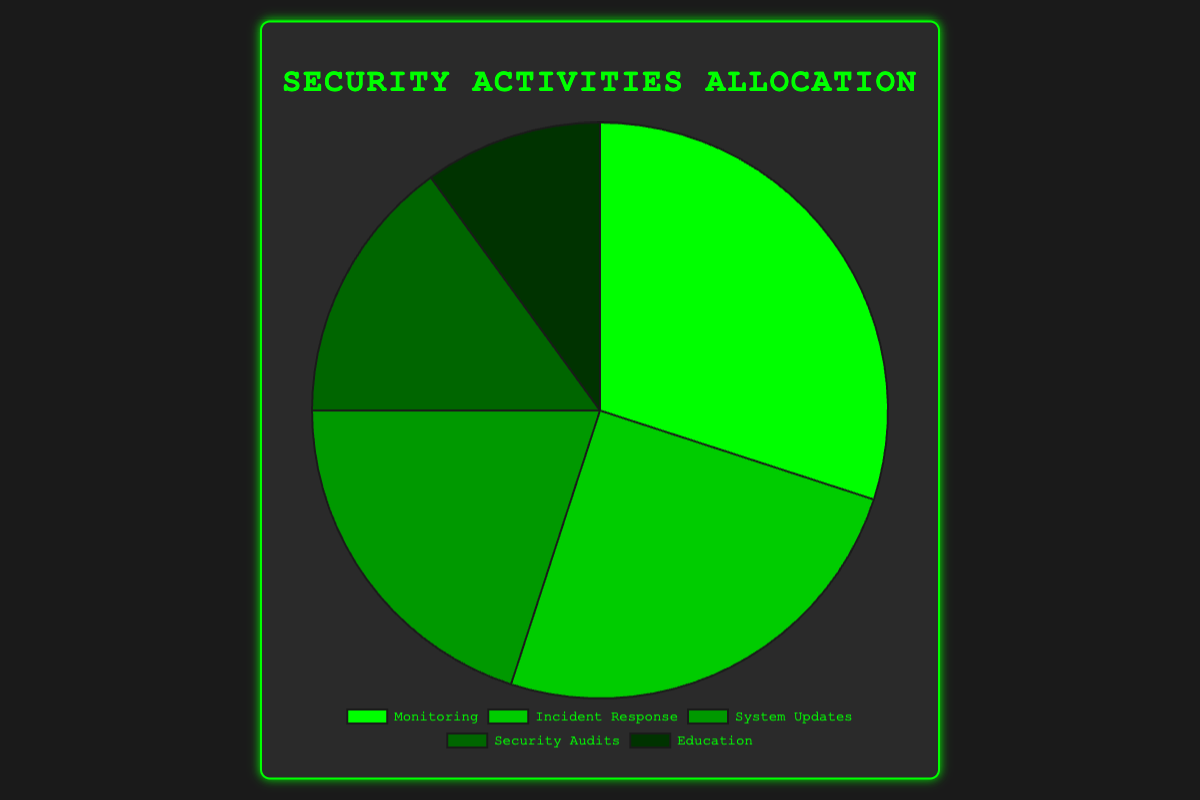What percentage of time is spent on Monitoring compared to Incident Response? The pie chart shows that 30% of time is spent on Monitoring and 25% on Incident Response. To compare, 30% - 25% = 5%.
Answer: 5% What is the total percentage of time allocated to System Updates and Security Audits combined? The pie chart indicates 20% for System Updates and 15% for Security Audits. Adding these percentages gives 20% + 15% = 35%.
Answer: 35% Which activity has the least allocation of time? From the pie chart, Education has the smallest portion of the pie, corresponding to 10%.
Answer: Education If you were to combine the time spent on Incident Response and Education, how does it compare to the time spent on Monitoring? The pie chart shows 25% for Incident Response and 10% for Education, totaling 25% + 10% = 35%. Monitoring is 30%. Thus, 35% - 30% = 5% more time is spent on Incident Response and Education combined than on Monitoring.
Answer: 5% more How much more time is spent on System Updates than on Education? The chart indicates 20% is spent on System Updates and 10% on Education. The difference is 20% - 10% = 10%.
Answer: 10% Which two activities together make up half of the total time allocation? Looking at the chart, Incident Response (25%) and Monitoring (30%) combined make up 25% + 30% = 55%. However, Security Audits (15%) and System Updates (20%) combined make up 15% + 20% = 35%, which is not half. Instead, Monitoring (30%) and System Updates (20%) add up to 30% + 20% = 50%. Therefore, Monitoring and System Updates together compose 50%.
Answer: Monitoring and System Updates What proportion of time is allocated to activities other than Education? From the chart, Education occupies 10% of the total. Therefore, the proportion of time allocated to other activities is 100% - 10% = 90%.
Answer: 90% If Security Audits and Education are combined, does their total time allocation exceed that of System Updates? Security Audits are given 15% and Education 10%. Combined, this is 15% + 10% = 25%. System Updates have a time allocation of 20%. Therefore, 25% is indeed greater than 20%.
Answer: Yes What is the ratio of time spent on Monitoring to the total time spent on Security Audits and Education combined? The chart shows that 30% of the time is spent on Monitoring. Security Audits are 15% and Education is 10%, combined to 15% + 10% = 25%. The ratio is 30% divided by 25%, or 30:25, which simplifies to 6:5.
Answer: 6:5 Which activity's time allocation shares the same color as the darkest shade of green? The pie chart uses progressively darker shades of green for each activity. The darkest green corresponds to Education, which is 10%.
Answer: Education 